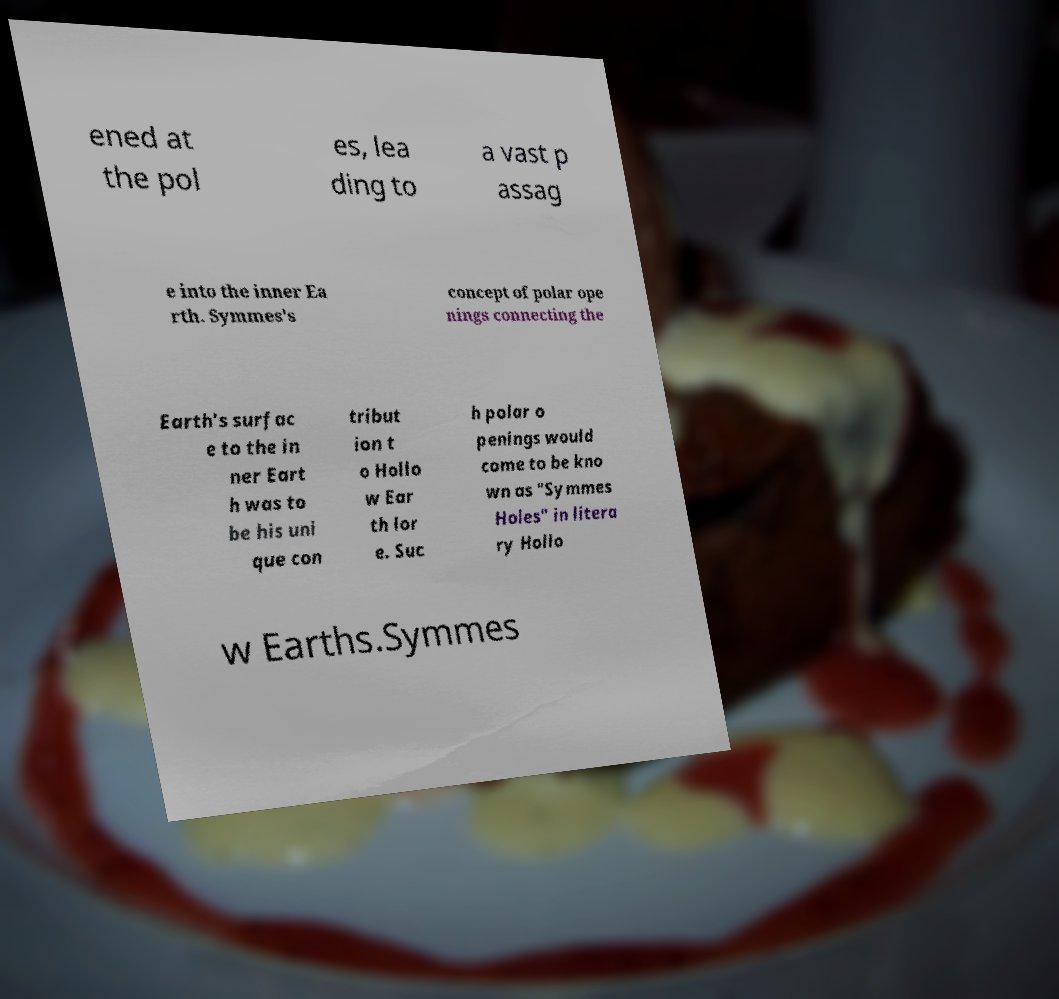Please read and relay the text visible in this image. What does it say? ened at the pol es, lea ding to a vast p assag e into the inner Ea rth. Symmes's concept of polar ope nings connecting the Earth's surfac e to the in ner Eart h was to be his uni que con tribut ion t o Hollo w Ear th lor e. Suc h polar o penings would come to be kno wn as "Symmes Holes" in litera ry Hollo w Earths.Symmes 